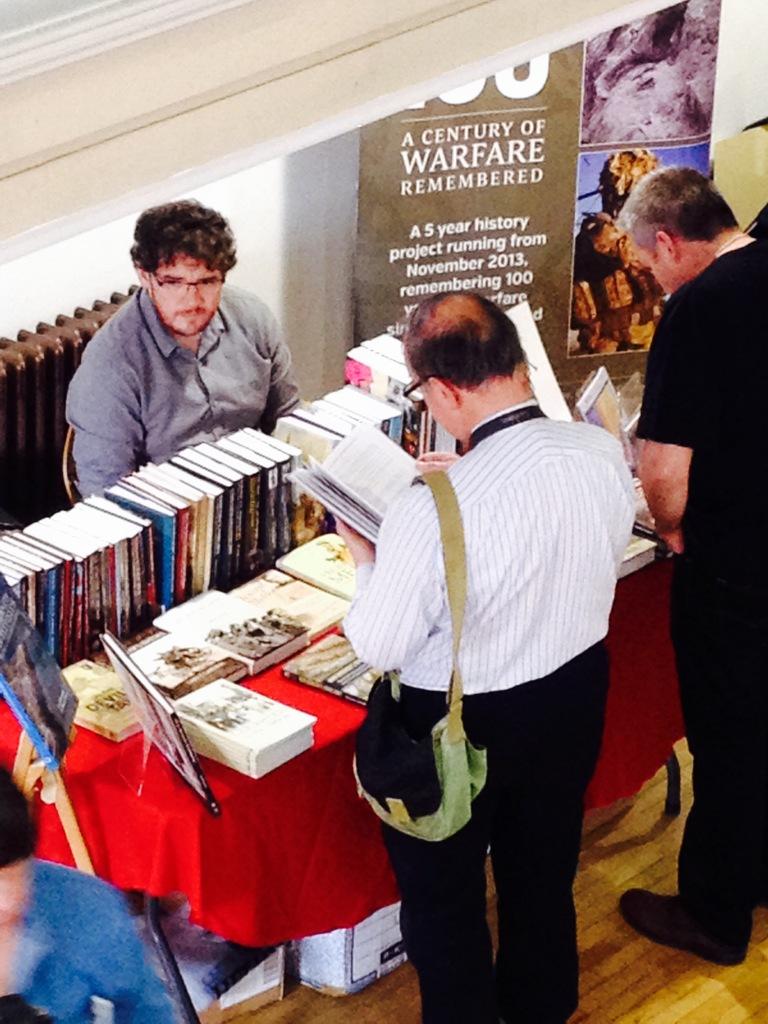How long is the history project according to the poster in the back?
Offer a terse response. 5 years. 